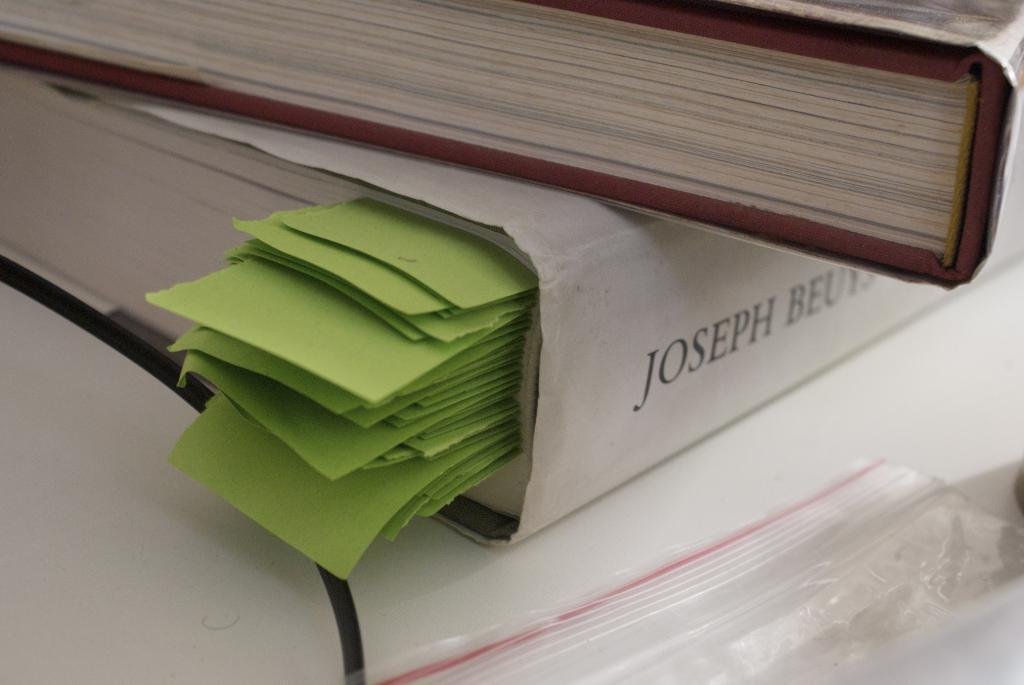Provide a one-sentence caption for the provided image. A picture of a thick book with green bookmarks that reads JOSEPH BEU. 